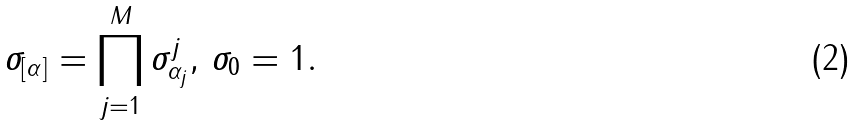<formula> <loc_0><loc_0><loc_500><loc_500>\sigma _ { [ \alpha ] } = \prod _ { j = 1 } ^ { M } \sigma _ { \alpha _ { j } } ^ { j } , \, \sigma _ { 0 } = 1 .</formula> 